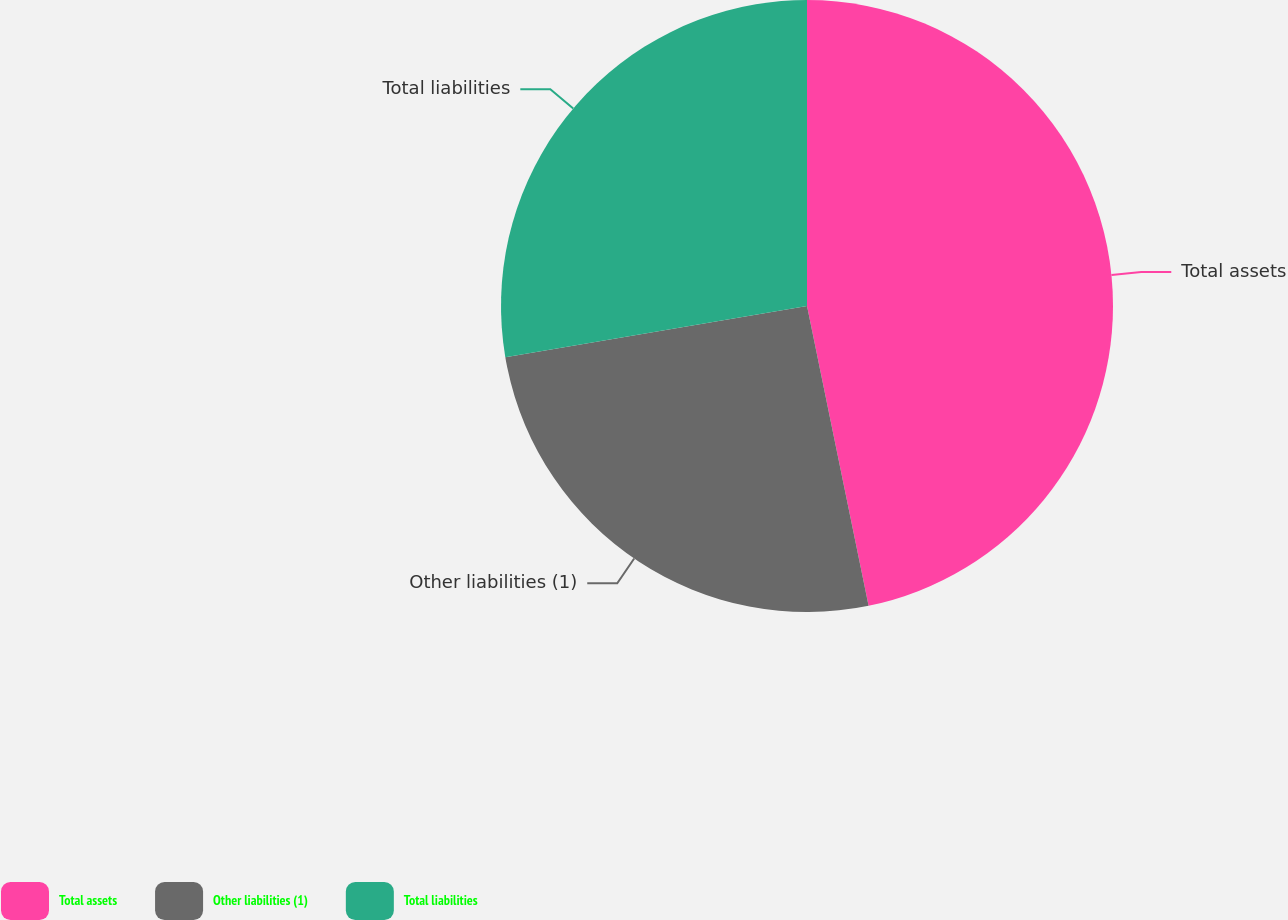Convert chart. <chart><loc_0><loc_0><loc_500><loc_500><pie_chart><fcel>Total assets<fcel>Other liabilities (1)<fcel>Total liabilities<nl><fcel>46.77%<fcel>25.55%<fcel>27.67%<nl></chart> 